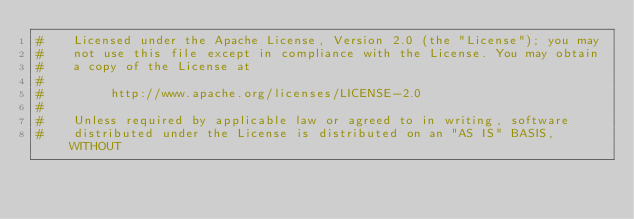<code> <loc_0><loc_0><loc_500><loc_500><_Python_>#    Licensed under the Apache License, Version 2.0 (the "License"); you may
#    not use this file except in compliance with the License. You may obtain
#    a copy of the License at
#
#         http://www.apache.org/licenses/LICENSE-2.0
#
#    Unless required by applicable law or agreed to in writing, software
#    distributed under the License is distributed on an "AS IS" BASIS, WITHOUT</code> 